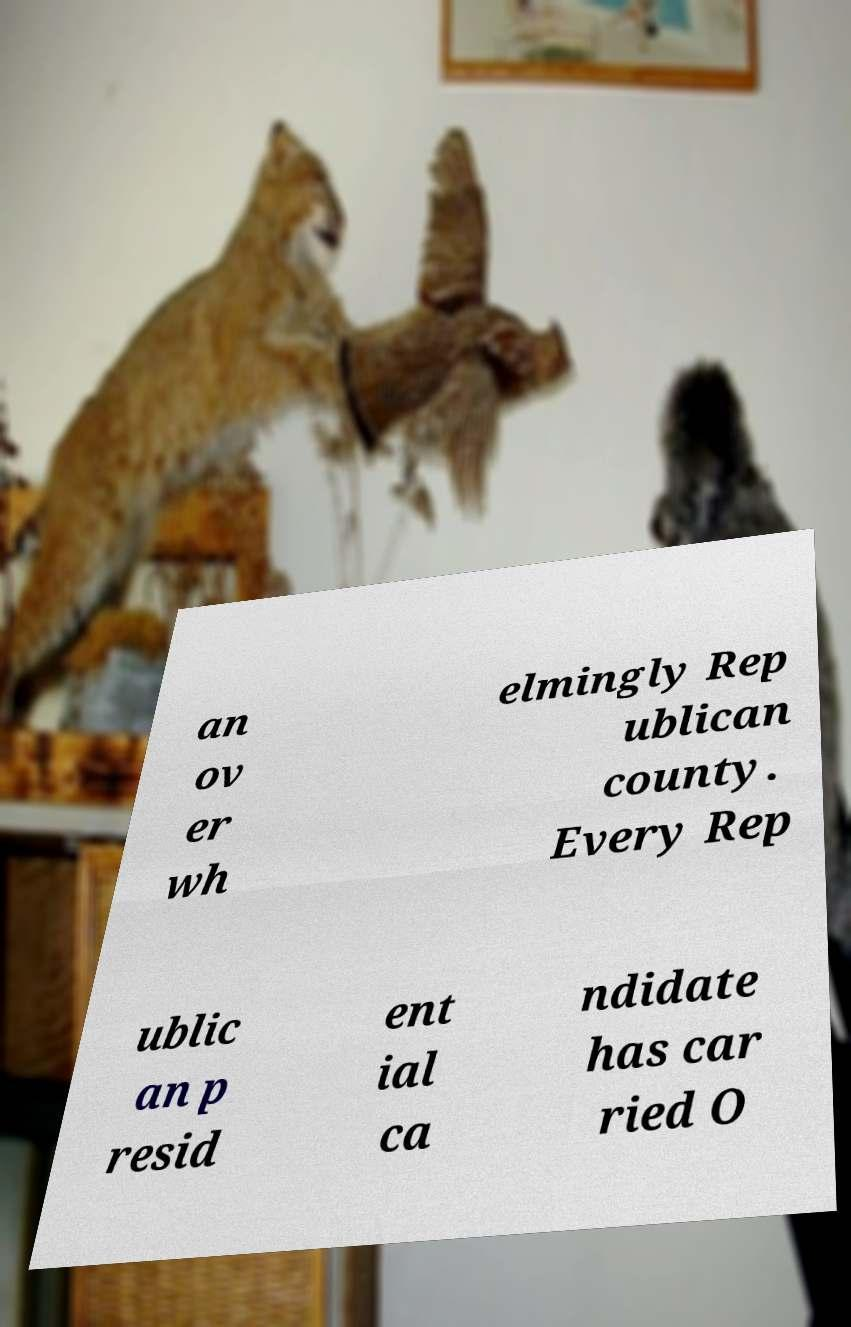Can you accurately transcribe the text from the provided image for me? an ov er wh elmingly Rep ublican county. Every Rep ublic an p resid ent ial ca ndidate has car ried O 